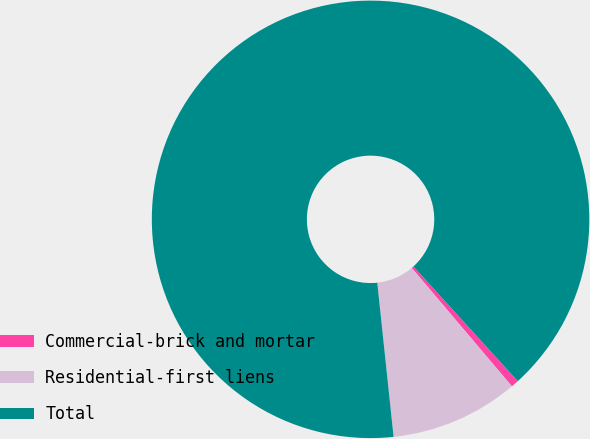Convert chart. <chart><loc_0><loc_0><loc_500><loc_500><pie_chart><fcel>Commercial-brick and mortar<fcel>Residential-first liens<fcel>Total<nl><fcel>0.57%<fcel>9.5%<fcel>89.93%<nl></chart> 